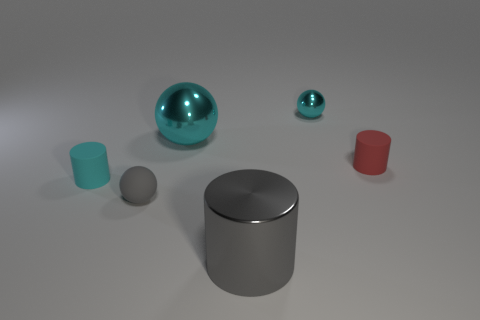What could be the function of these objects? The objects appear to be simple geometric shapes likely meant for visual or artistic purposes, perhaps as part of a 3D modeling demonstration or a study in shading and rendering techniques. Could the lighting in the scene be from a natural source? The soft shadows and even lighting suggest that the illumination could be from a simulated global light source, akin to an overcast sky, rather than the direct light one would expect from a natural source like the sun. 